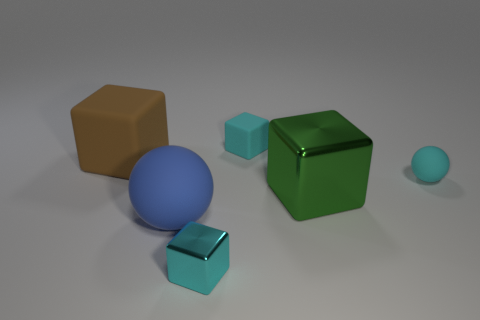Add 3 big blue cylinders. How many objects exist? 9 Subtract all blocks. How many objects are left? 2 Add 4 big green cubes. How many big green cubes exist? 5 Subtract 0 yellow cylinders. How many objects are left? 6 Subtract all large brown matte things. Subtract all green shiny things. How many objects are left? 4 Add 1 small cyan metallic things. How many small cyan metallic things are left? 2 